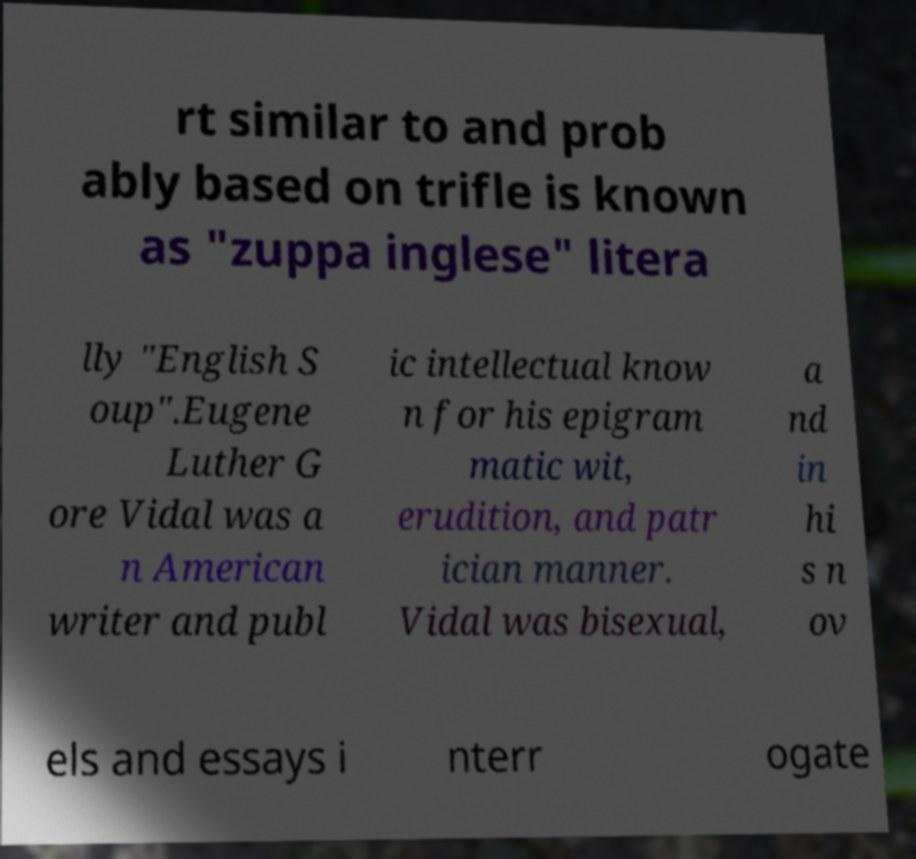For documentation purposes, I need the text within this image transcribed. Could you provide that? rt similar to and prob ably based on trifle is known as "zuppa inglese" litera lly "English S oup".Eugene Luther G ore Vidal was a n American writer and publ ic intellectual know n for his epigram matic wit, erudition, and patr ician manner. Vidal was bisexual, a nd in hi s n ov els and essays i nterr ogate 